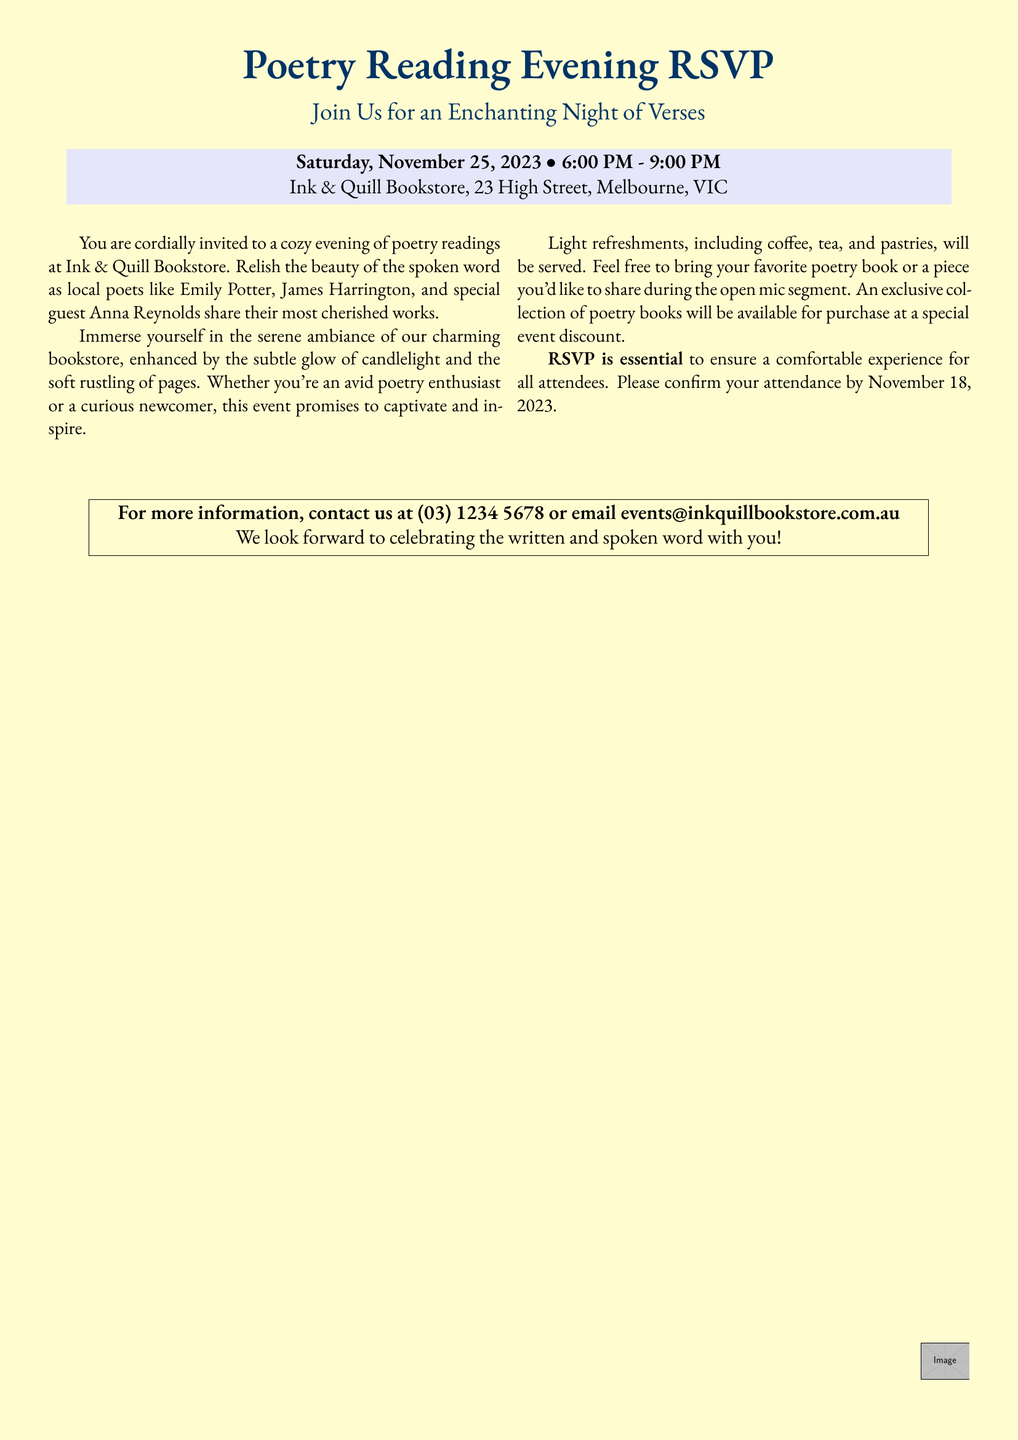What is the date of the event? The date is specified in the document as Saturday, November 25, 2023.
Answer: Saturday, November 25, 2023 What time does the event start? The start time is given in the document as 6:00 PM.
Answer: 6:00 PM Who is the special guest poet? The special guest poet is mentioned in the document as Anna Reynolds.
Answer: Anna Reynolds What refreshments will be served? The document lists coffee, tea, and pastries as the refreshments served during the event.
Answer: Coffee, tea, and pastries When is the RSVP deadline? The RSVP deadline is indicated in the document as November 18, 2023.
Answer: November 18, 2023 What is the main theme of the event? The document describes the event as a cozy evening of poetry readings, indicating its main theme is poetry.
Answer: Poetry readings Where is the event taking place? The location of the event is stated in the document as Ink & Quill Bookstore, 23 High Street, Melbourne, VIC.
Answer: Ink & Quill Bookstore, 23 High Street, Melbourne, VIC Is there an open mic segment? The document notes that attendees are encouraged to bring a piece to share during the open mic segment, indicating its presence.
Answer: Yes 